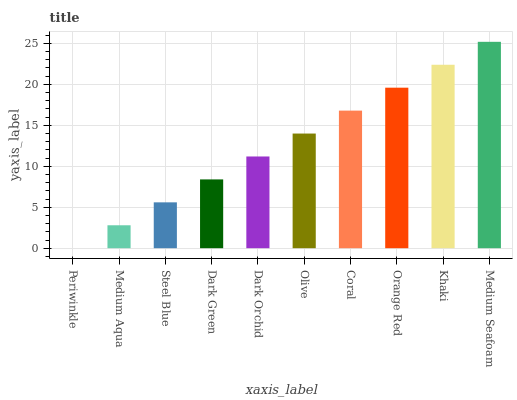Is Periwinkle the minimum?
Answer yes or no. Yes. Is Medium Seafoam the maximum?
Answer yes or no. Yes. Is Medium Aqua the minimum?
Answer yes or no. No. Is Medium Aqua the maximum?
Answer yes or no. No. Is Medium Aqua greater than Periwinkle?
Answer yes or no. Yes. Is Periwinkle less than Medium Aqua?
Answer yes or no. Yes. Is Periwinkle greater than Medium Aqua?
Answer yes or no. No. Is Medium Aqua less than Periwinkle?
Answer yes or no. No. Is Olive the high median?
Answer yes or no. Yes. Is Dark Orchid the low median?
Answer yes or no. Yes. Is Periwinkle the high median?
Answer yes or no. No. Is Khaki the low median?
Answer yes or no. No. 